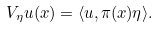<formula> <loc_0><loc_0><loc_500><loc_500>V _ { \eta } u ( x ) = \langle u , \pi ( x ) \eta \rangle .</formula> 